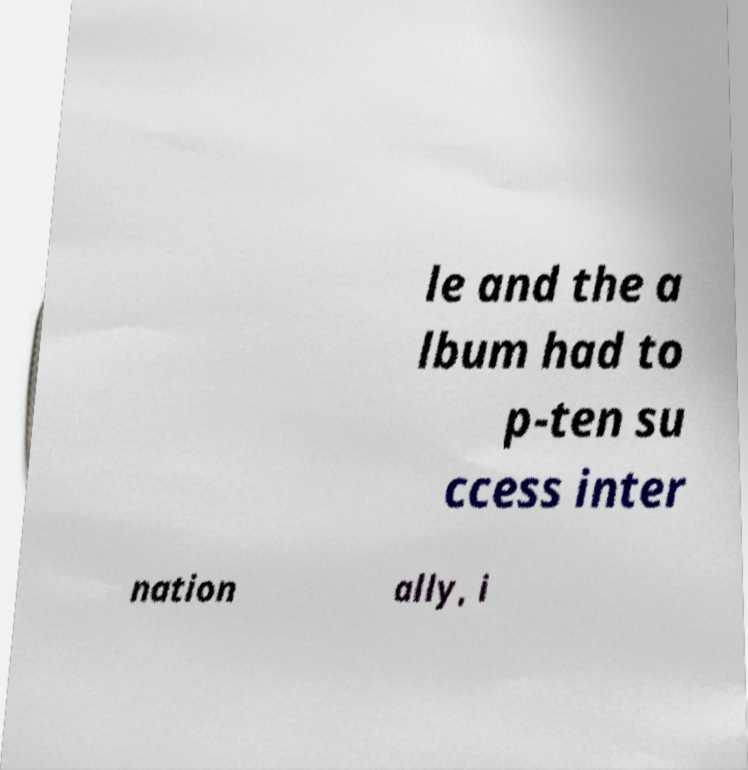What messages or text are displayed in this image? I need them in a readable, typed format. le and the a lbum had to p-ten su ccess inter nation ally, i 